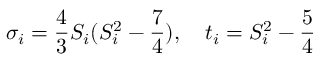Convert formula to latex. <formula><loc_0><loc_0><loc_500><loc_500>{ \sigma } _ { i } = { \frac { 4 } { 3 } } S _ { i } ( S _ { i } ^ { 2 } - { \frac { 7 } { 4 } } ) , \quad t _ { i } = S _ { i } ^ { 2 } - { \frac { 5 } { 4 } }</formula> 